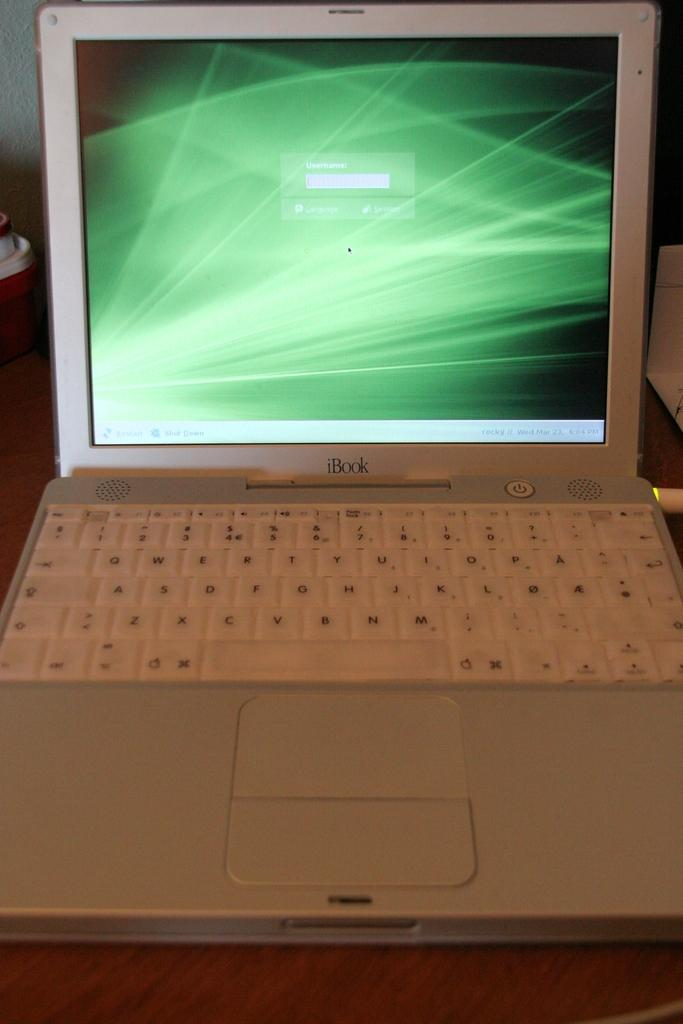<image>
Present a compact description of the photo's key features. An iBook opened to the login screen where users are to write their username. 